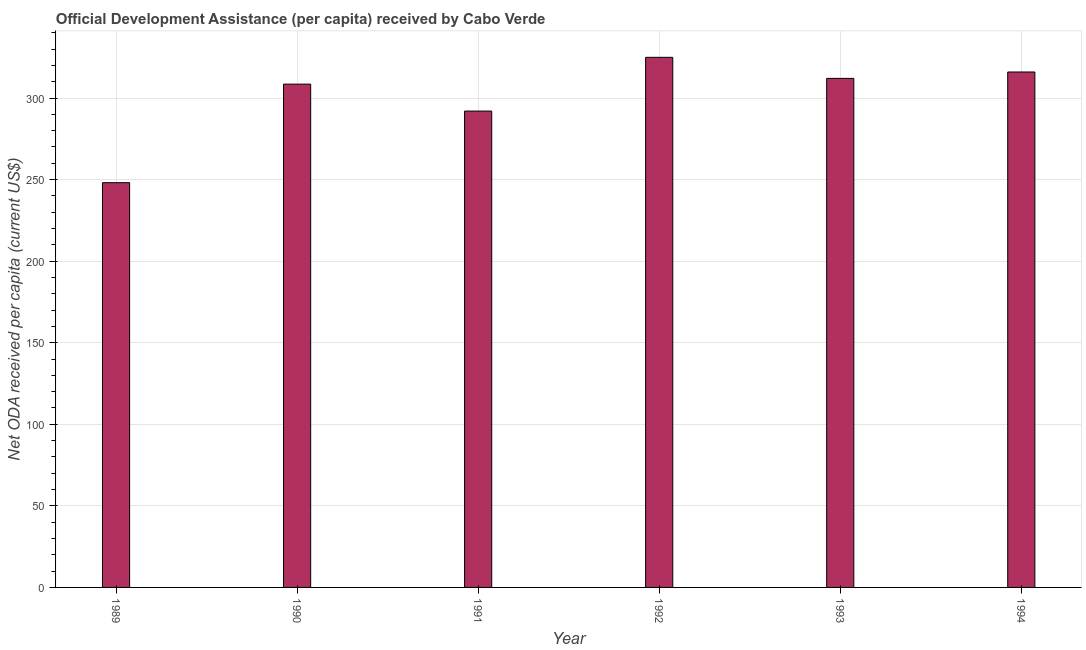Does the graph contain grids?
Offer a terse response. Yes. What is the title of the graph?
Keep it short and to the point. Official Development Assistance (per capita) received by Cabo Verde. What is the label or title of the Y-axis?
Give a very brief answer. Net ODA received per capita (current US$). What is the net oda received per capita in 1990?
Keep it short and to the point. 308.51. Across all years, what is the maximum net oda received per capita?
Provide a succinct answer. 324.93. Across all years, what is the minimum net oda received per capita?
Provide a succinct answer. 248.09. In which year was the net oda received per capita maximum?
Make the answer very short. 1992. What is the sum of the net oda received per capita?
Your response must be concise. 1801.51. What is the difference between the net oda received per capita in 1992 and 1993?
Provide a short and direct response. 12.9. What is the average net oda received per capita per year?
Provide a succinct answer. 300.25. What is the median net oda received per capita?
Make the answer very short. 310.27. In how many years, is the net oda received per capita greater than 290 US$?
Offer a very short reply. 5. What is the ratio of the net oda received per capita in 1992 to that in 1994?
Ensure brevity in your answer.  1.03. What is the difference between the highest and the second highest net oda received per capita?
Make the answer very short. 8.98. What is the difference between the highest and the lowest net oda received per capita?
Offer a terse response. 76.84. In how many years, is the net oda received per capita greater than the average net oda received per capita taken over all years?
Give a very brief answer. 4. Are all the bars in the graph horizontal?
Your answer should be compact. No. How many years are there in the graph?
Your answer should be compact. 6. What is the Net ODA received per capita (current US$) in 1989?
Give a very brief answer. 248.09. What is the Net ODA received per capita (current US$) of 1990?
Offer a terse response. 308.51. What is the Net ODA received per capita (current US$) of 1991?
Provide a short and direct response. 291.99. What is the Net ODA received per capita (current US$) of 1992?
Make the answer very short. 324.93. What is the Net ODA received per capita (current US$) of 1993?
Your answer should be compact. 312.03. What is the Net ODA received per capita (current US$) in 1994?
Make the answer very short. 315.95. What is the difference between the Net ODA received per capita (current US$) in 1989 and 1990?
Offer a terse response. -60.42. What is the difference between the Net ODA received per capita (current US$) in 1989 and 1991?
Keep it short and to the point. -43.9. What is the difference between the Net ODA received per capita (current US$) in 1989 and 1992?
Your answer should be compact. -76.84. What is the difference between the Net ODA received per capita (current US$) in 1989 and 1993?
Ensure brevity in your answer.  -63.94. What is the difference between the Net ODA received per capita (current US$) in 1989 and 1994?
Provide a succinct answer. -67.86. What is the difference between the Net ODA received per capita (current US$) in 1990 and 1991?
Your answer should be very brief. 16.52. What is the difference between the Net ODA received per capita (current US$) in 1990 and 1992?
Make the answer very short. -16.43. What is the difference between the Net ODA received per capita (current US$) in 1990 and 1993?
Provide a short and direct response. -3.53. What is the difference between the Net ODA received per capita (current US$) in 1990 and 1994?
Provide a succinct answer. -7.44. What is the difference between the Net ODA received per capita (current US$) in 1991 and 1992?
Offer a very short reply. -32.94. What is the difference between the Net ODA received per capita (current US$) in 1991 and 1993?
Your answer should be very brief. -20.04. What is the difference between the Net ODA received per capita (current US$) in 1991 and 1994?
Provide a succinct answer. -23.96. What is the difference between the Net ODA received per capita (current US$) in 1992 and 1993?
Your answer should be very brief. 12.9. What is the difference between the Net ODA received per capita (current US$) in 1992 and 1994?
Give a very brief answer. 8.98. What is the difference between the Net ODA received per capita (current US$) in 1993 and 1994?
Offer a very short reply. -3.92. What is the ratio of the Net ODA received per capita (current US$) in 1989 to that in 1990?
Offer a terse response. 0.8. What is the ratio of the Net ODA received per capita (current US$) in 1989 to that in 1991?
Your response must be concise. 0.85. What is the ratio of the Net ODA received per capita (current US$) in 1989 to that in 1992?
Your response must be concise. 0.76. What is the ratio of the Net ODA received per capita (current US$) in 1989 to that in 1993?
Offer a very short reply. 0.8. What is the ratio of the Net ODA received per capita (current US$) in 1989 to that in 1994?
Your answer should be compact. 0.79. What is the ratio of the Net ODA received per capita (current US$) in 1990 to that in 1991?
Keep it short and to the point. 1.06. What is the ratio of the Net ODA received per capita (current US$) in 1990 to that in 1992?
Your response must be concise. 0.95. What is the ratio of the Net ODA received per capita (current US$) in 1990 to that in 1993?
Your answer should be very brief. 0.99. What is the ratio of the Net ODA received per capita (current US$) in 1991 to that in 1992?
Keep it short and to the point. 0.9. What is the ratio of the Net ODA received per capita (current US$) in 1991 to that in 1993?
Your answer should be compact. 0.94. What is the ratio of the Net ODA received per capita (current US$) in 1991 to that in 1994?
Provide a succinct answer. 0.92. What is the ratio of the Net ODA received per capita (current US$) in 1992 to that in 1993?
Your response must be concise. 1.04. What is the ratio of the Net ODA received per capita (current US$) in 1992 to that in 1994?
Your answer should be compact. 1.03. What is the ratio of the Net ODA received per capita (current US$) in 1993 to that in 1994?
Your answer should be compact. 0.99. 